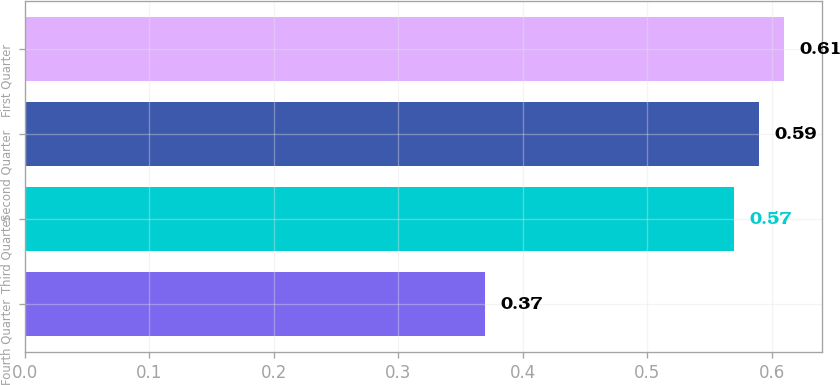Convert chart to OTSL. <chart><loc_0><loc_0><loc_500><loc_500><bar_chart><fcel>Fourth Quarter<fcel>Third Quarter<fcel>Second Quarter<fcel>First Quarter<nl><fcel>0.37<fcel>0.57<fcel>0.59<fcel>0.61<nl></chart> 